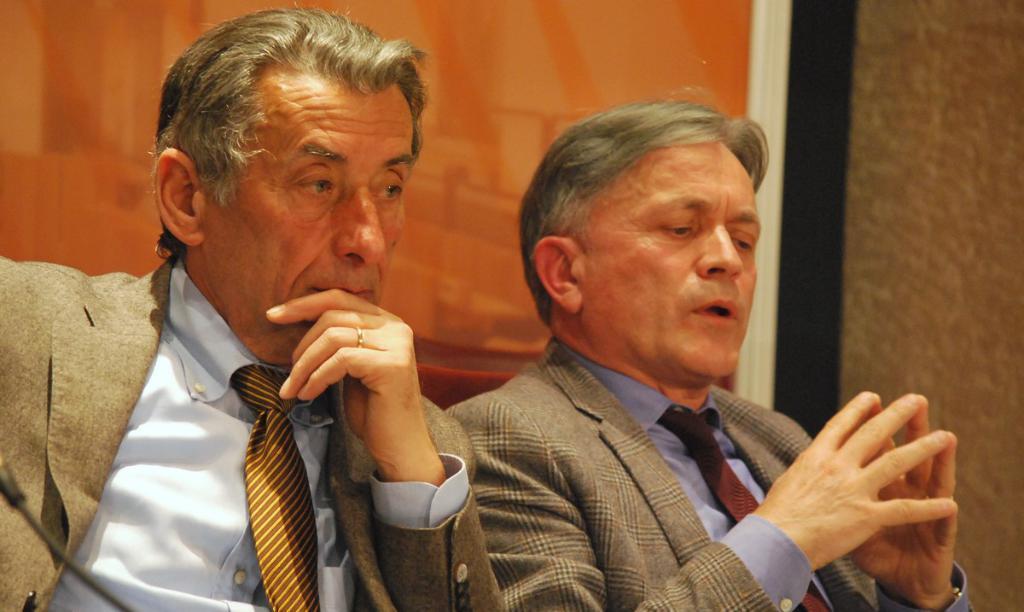Can you describe this image briefly? In this image, we can see two men in suits. In the background, there is a wall and picture frame. 